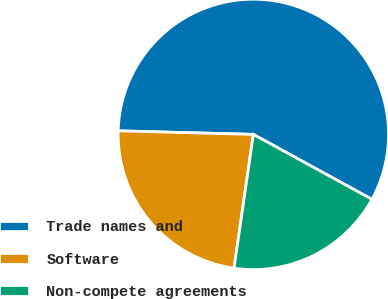Convert chart to OTSL. <chart><loc_0><loc_0><loc_500><loc_500><pie_chart><fcel>Trade names and<fcel>Software<fcel>Non-compete agreements<nl><fcel>57.55%<fcel>23.14%<fcel>19.31%<nl></chart> 